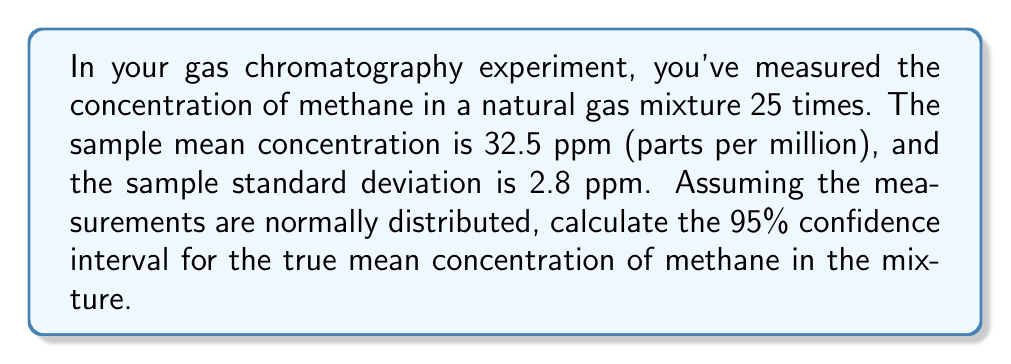Show me your answer to this math problem. To calculate the confidence interval, we'll follow these steps:

1) For a 95% confidence interval, we use the t-distribution with n-1 degrees of freedom.

2) The formula for the confidence interval is:

   $$\bar{x} \pm t_{\alpha/2, n-1} \cdot \frac{s}{\sqrt{n}}$$

   where:
   $\bar{x}$ is the sample mean
   $s$ is the sample standard deviation
   $n$ is the sample size
   $t_{\alpha/2, n-1}$ is the t-value for a 95% confidence level with n-1 degrees of freedom

3) We have:
   $\bar{x} = 32.5$ ppm
   $s = 2.8$ ppm
   $n = 25$
   degrees of freedom = 25 - 1 = 24

4) For a 95% confidence interval with 24 degrees of freedom, $t_{0.025, 24} = 2.064$ (from t-distribution table)

5) Calculate the margin of error:

   $$2.064 \cdot \frac{2.8}{\sqrt{25}} = 2.064 \cdot 0.56 = 1.16$$

6) The confidence interval is therefore:

   $$32.5 \pm 1.16$$

   or (32.5 - 1.16, 32.5 + 1.16)
Answer: (31.34 ppm, 33.66 ppm) 